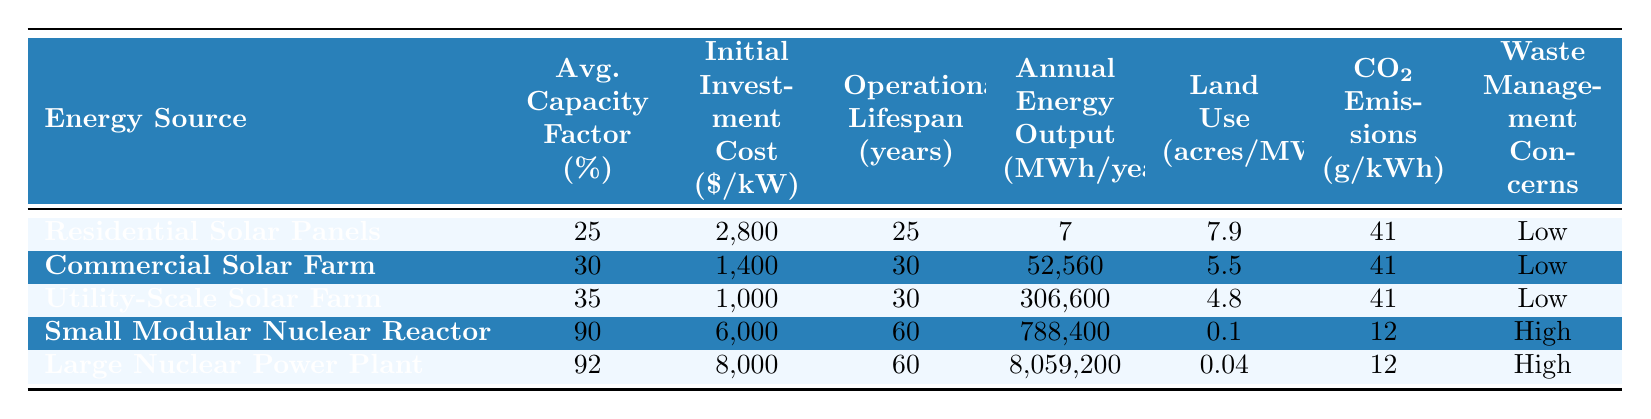What is the average capacity factor of residential solar panels? The table shows that the average capacity factor of residential solar panels is listed under the corresponding column, which is 25%.
Answer: 25% Which energy source has the highest initial investment cost per kW? By comparing the initial investment costs of all energy sources listed, the Large Nuclear Power Plant has the highest cost at $8,000 per kW.
Answer: $8,000 What is the annual energy output of a Utility-Scale Solar Farm? The table indicates that a Utility-Scale Solar Farm produces 306,600 MWh/year as its annual energy output.
Answer: 306,600 MWh/year Do all solar energy sources have low waste management concerns? The waste management concerns for all solar energy sources in the table are categorized as Low, confirmed by checking the respective column for those entries.
Answer: Yes What is the average operational lifespan of nuclear power plants indicated? The operational lifespan of the Small Modular Nuclear Reactor is 60 years and the Large Nuclear Power Plant is also 60 years. Therefore, the average lifespan is (60 + 60) / 2 = 60 years.
Answer: 60 years How much lower is the land use of a Large Nuclear Power Plant compared to a Commercial Solar Farm? The land use for a Large Nuclear Power Plant is 0.04 acres/MW while for a Commercial Solar Farm it is 5.5 acres/MW. The difference is 5.5 - 0.04 = 5.46 acres/MW.
Answer: 5.46 acres/MW Is the CO2 emissions of a Small Modular Nuclear Reactor higher than that of solar panels? The CO2 emissions for a Small Modular Nuclear Reactor are 12 g/kWh, while all solar sources produce only 41 g/kWh, making nuclear emissions lower.
Answer: No If a utility-scale solar farm operates at its average capacity, how much energy can it output in 30 years? The annual energy output is 306,600 MWh/year. Thus in 30 years, the total output is 306,600 * 30 = 9,198,000 MWh.
Answer: 9,198,000 MWh What energy source has the lowest land use per MW? By looking at the land use column, the Small Modular Nuclear Reactor has the lowest at 0.1 acres/MW.
Answer: Small Modular Nuclear Reactor How do the average CO2 emissions of nuclear plants compare to solar panels? Nuclear power plants emit 12 g/kWh, while solar panels emit 41 g/kWh on average. Since 12 is less than 41, nuclear plants have lower CO2 emissions compared to solar panels.
Answer: Lower 